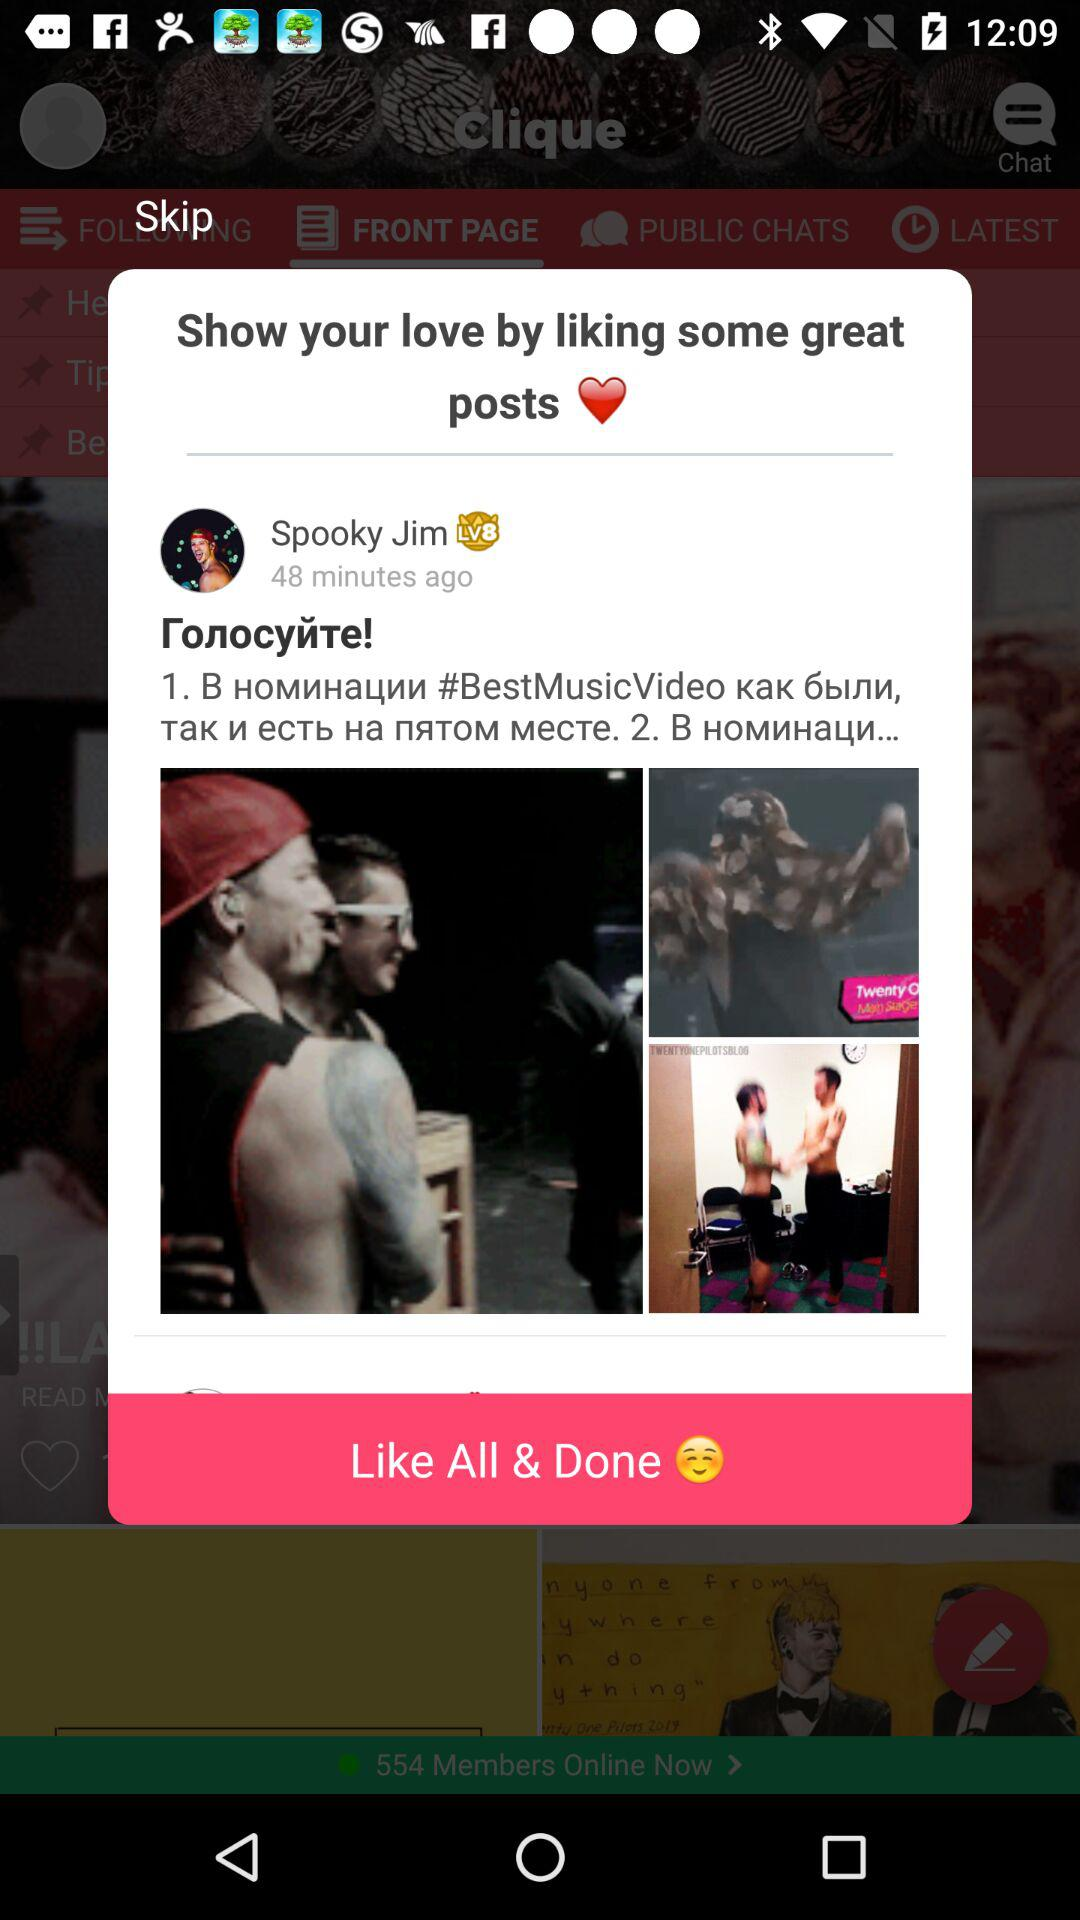What is the name of the user? The name of the user is Spooky Jim. 